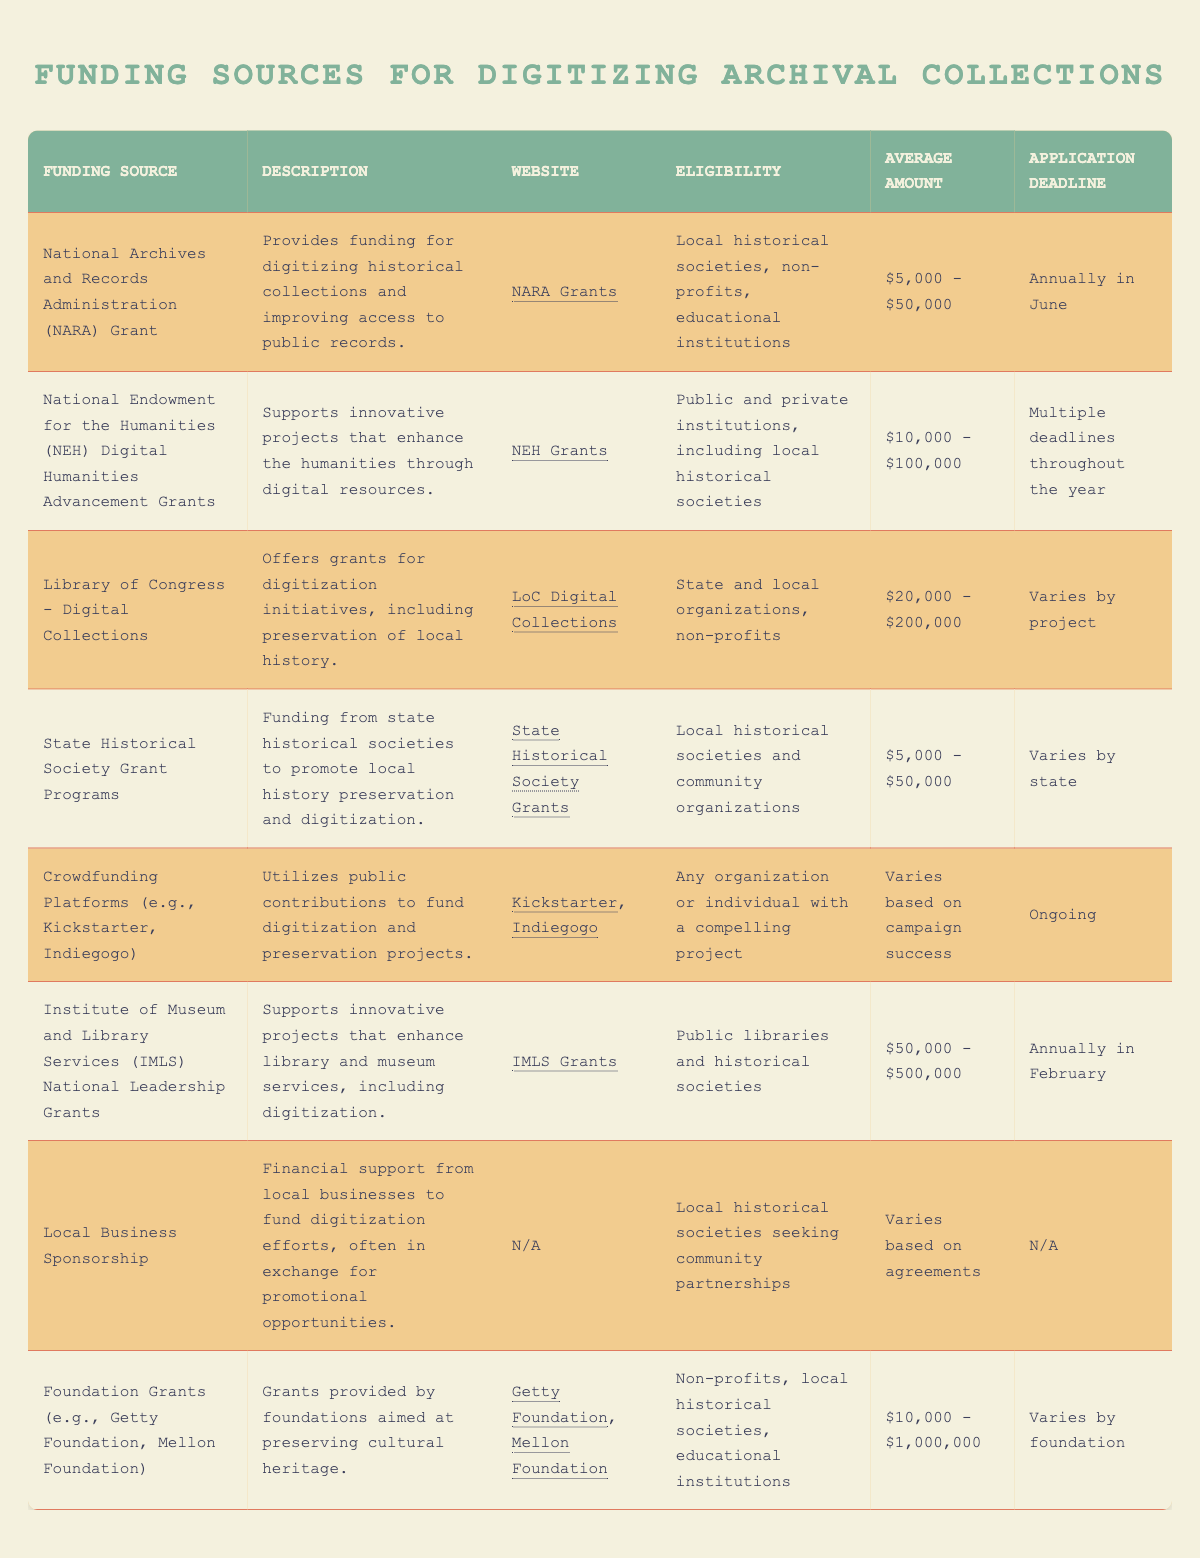What is the average funding amount for the National Archives and Records Administration (NARA) Grant? The National Archives and Records Administration (NARA) Grant has an average funding amount of $5,000 to $50,000. The average can be estimated as the midpoint: (5000 + 50000) / 2 = 27750.
Answer: $27,750 How many funding sources have an application deadline in February? There is one funding source listed in the table with an application deadline in February, which is the Institute of Museum and Library Services (IMLS) National Leadership Grants.
Answer: 1 Which funding source has the highest average amount available? The Foundation Grants (e.g., Getty Foundation, Mellon Foundation) offer the highest average amount, which is $10,000 to $1,000,000.
Answer: $10,000 - $1,000,000 Are local historical societies eligible for the Library of Congress - Digital Collections funding? Yes, local historical societies are eligible as the description states that the funding is available for state and local organizations, non-profits.
Answer: Yes What is the combined average funding amount for the National Endowment for the Humanities (NEH) Digital Humanities Advancement Grants and the State Historical Society Grant Programs? The average amount for the NEH Grant is $10,000 - $100,000, which can be averaged to $55,000. The State Historical Society Grant Programs average $5,000 - $50,000, averaging to $27,500. Therefore, the combined average is (55000 + 27500) / 2 = 41,250.
Answer: $41,250 Is the application deadline for crowdfunding platforms ongoing? Yes, the application deadline for crowdfunding platforms is listed as ongoing, meaning there is no specific cutoff date.
Answer: Yes Which funding source requires the most extensive eligibility criteria? The funding source with the most extensive eligibility criteria is the Institute of Museum and Library Services (IMLS) National Leadership Grants, which are available to public libraries and historical societies, implying a more specialized audience compared to others.
Answer: Institute of Museum and Library Services (IMLS) National Leadership Grants How many funding sources are available to individuals or organizations utilizing crowdfunding? There is one funding source available for individuals or organizations using crowdfunding: Crowdfunding Platforms (e.g., Kickstarter, Indiegogo), which clearly states that any organization or individual with a compelling project can participate.
Answer: 1 What is the total number of funding sources listed? There are eight funding sources listed in the table. Each source is a separate entry, and counting them provides a total of eight.
Answer: 8 